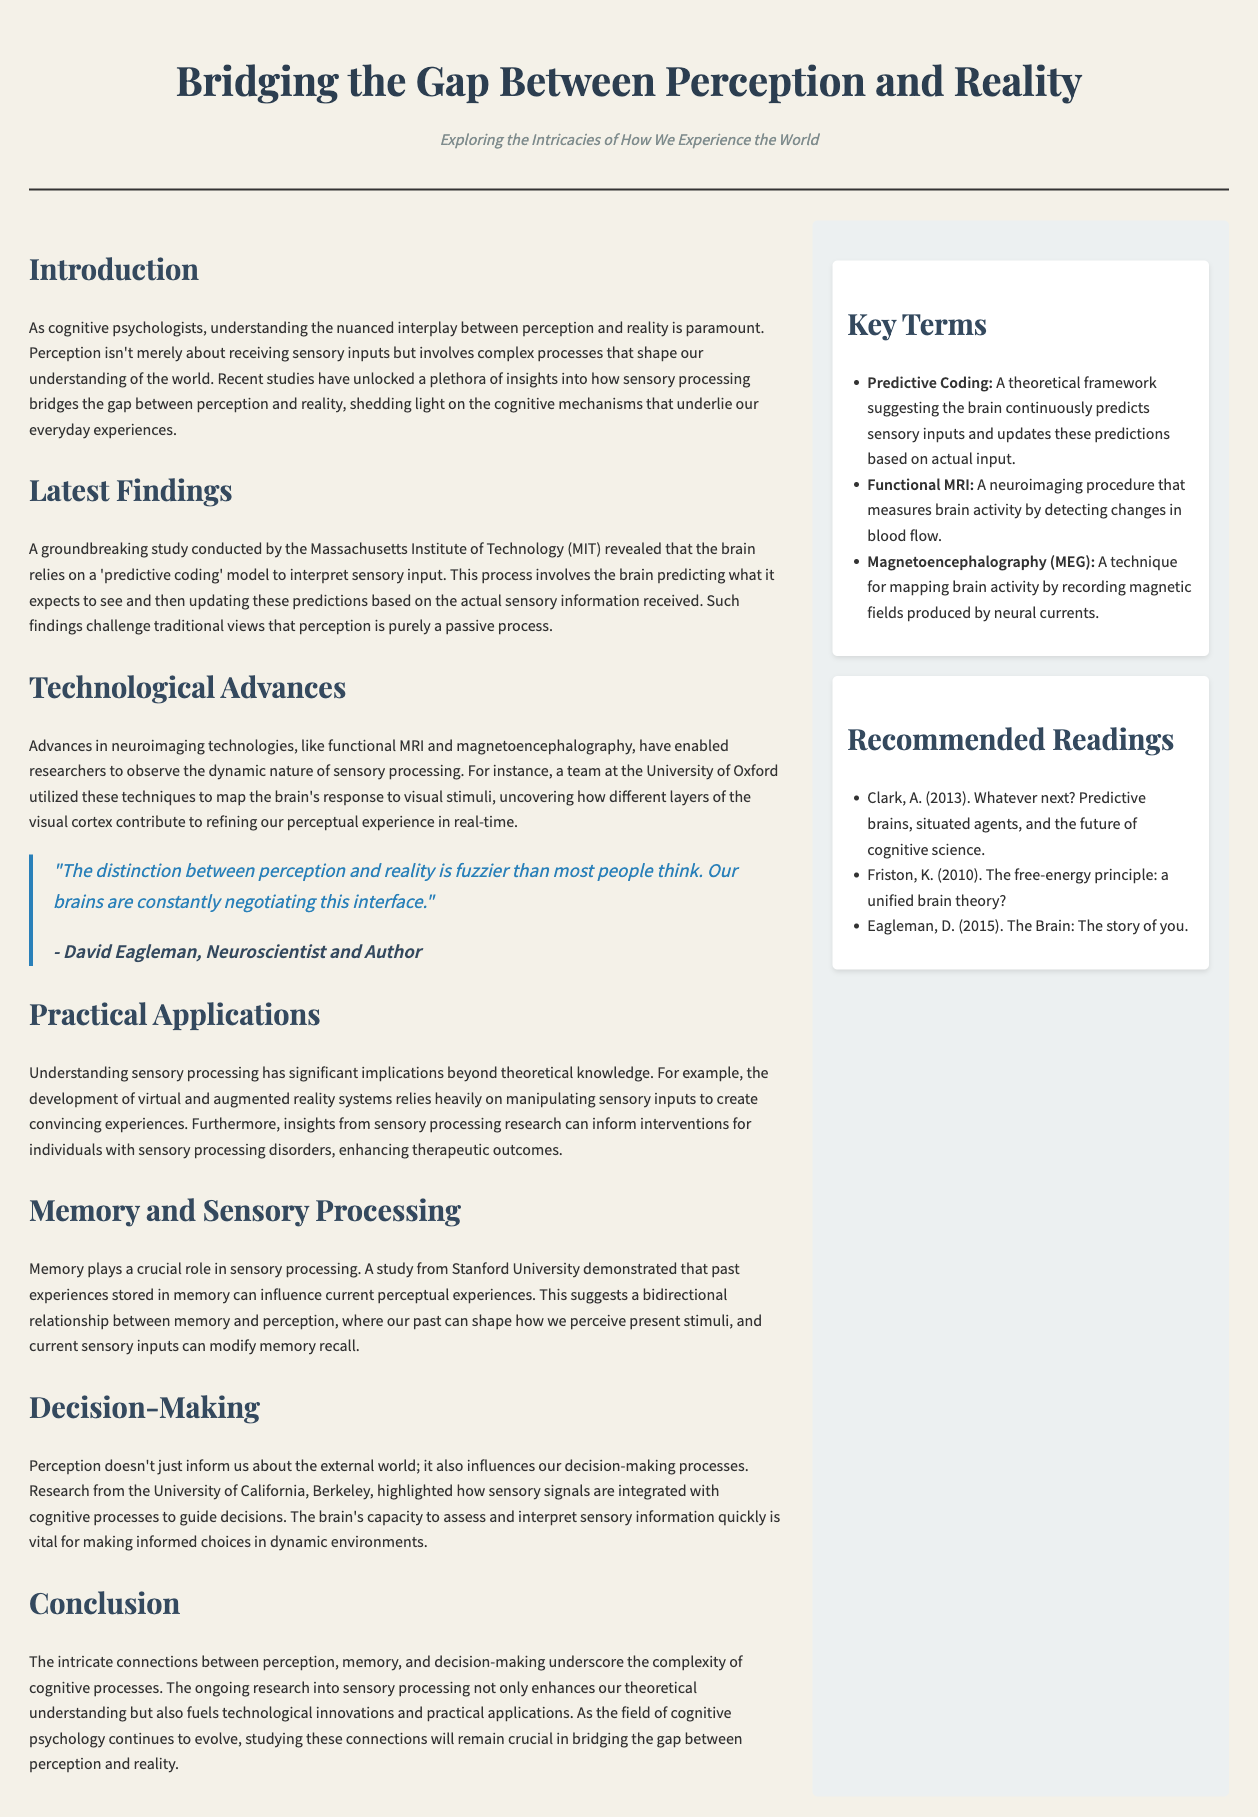what is the title of the document? The title of the document is provided at the top of the layout in a prominent position as the main heading.
Answer: Bridging the Gap Between Perception and Reality who conducted a groundbreaking study on sensory processing? The document mentions that the study was conducted by a specific institution known for its research in cognitive science.
Answer: Massachusetts Institute of Technology (MIT) what key term is defined as a theoretical framework for the brain's predictions? The definition of a key term within the sidebar explains this cognitive concept.
Answer: Predictive Coding who is quoted in the document regarding perception and reality? The quote included in the document attributes a statement about perception and reality to a noted scientist.
Answer: David Eagleman which university demonstrated the influence of memory on perception? A specific university is referenced in the section discussing memory and sensory processing, showcasing its significance in research on this connection.
Answer: Stanford University what neuroimaging technology is mentioned for mapping brain activity? The document lists specific technologies used in research including one commonly associated with brain activity measurement.
Answer: Functional MRI how does the brain interpret sensory input according to the latest findings? The explanation provided in the document describes how the brain utilizes a certain model to process sensory information.
Answer: Predictive coding model what section discusses the implications of sensory processing for virtual reality? The document has a specific segment that addresses practical applications of sensory processing findings in modern technology.
Answer: Practical Applications 